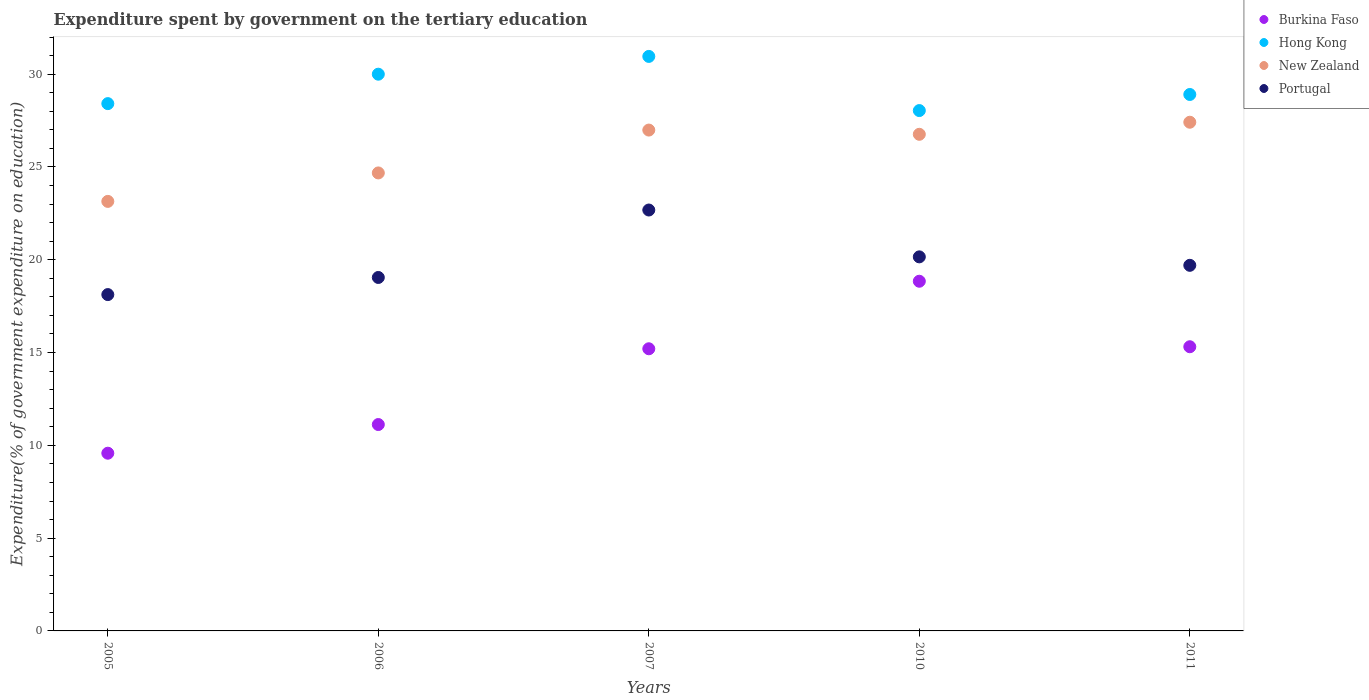How many different coloured dotlines are there?
Ensure brevity in your answer.  4. Is the number of dotlines equal to the number of legend labels?
Ensure brevity in your answer.  Yes. What is the expenditure spent by government on the tertiary education in Hong Kong in 2005?
Your answer should be very brief. 28.41. Across all years, what is the maximum expenditure spent by government on the tertiary education in Burkina Faso?
Provide a short and direct response. 18.84. Across all years, what is the minimum expenditure spent by government on the tertiary education in New Zealand?
Give a very brief answer. 23.14. In which year was the expenditure spent by government on the tertiary education in New Zealand maximum?
Offer a terse response. 2011. In which year was the expenditure spent by government on the tertiary education in New Zealand minimum?
Make the answer very short. 2005. What is the total expenditure spent by government on the tertiary education in New Zealand in the graph?
Offer a very short reply. 128.97. What is the difference between the expenditure spent by government on the tertiary education in Portugal in 2007 and that in 2011?
Keep it short and to the point. 2.98. What is the difference between the expenditure spent by government on the tertiary education in New Zealand in 2011 and the expenditure spent by government on the tertiary education in Hong Kong in 2010?
Provide a short and direct response. -0.63. What is the average expenditure spent by government on the tertiary education in Portugal per year?
Make the answer very short. 19.94. In the year 2010, what is the difference between the expenditure spent by government on the tertiary education in Portugal and expenditure spent by government on the tertiary education in New Zealand?
Provide a short and direct response. -6.6. In how many years, is the expenditure spent by government on the tertiary education in Burkina Faso greater than 22 %?
Your response must be concise. 0. What is the ratio of the expenditure spent by government on the tertiary education in Portugal in 2005 to that in 2011?
Provide a succinct answer. 0.92. What is the difference between the highest and the second highest expenditure spent by government on the tertiary education in New Zealand?
Give a very brief answer. 0.42. What is the difference between the highest and the lowest expenditure spent by government on the tertiary education in Hong Kong?
Ensure brevity in your answer.  2.92. Is it the case that in every year, the sum of the expenditure spent by government on the tertiary education in Burkina Faso and expenditure spent by government on the tertiary education in New Zealand  is greater than the sum of expenditure spent by government on the tertiary education in Hong Kong and expenditure spent by government on the tertiary education in Portugal?
Provide a short and direct response. No. Is the expenditure spent by government on the tertiary education in Portugal strictly less than the expenditure spent by government on the tertiary education in New Zealand over the years?
Keep it short and to the point. Yes. How many dotlines are there?
Give a very brief answer. 4. Does the graph contain any zero values?
Keep it short and to the point. No. Where does the legend appear in the graph?
Your response must be concise. Top right. How many legend labels are there?
Ensure brevity in your answer.  4. How are the legend labels stacked?
Keep it short and to the point. Vertical. What is the title of the graph?
Your answer should be compact. Expenditure spent by government on the tertiary education. What is the label or title of the X-axis?
Your response must be concise. Years. What is the label or title of the Y-axis?
Your answer should be very brief. Expenditure(% of government expenditure on education). What is the Expenditure(% of government expenditure on education) of Burkina Faso in 2005?
Your response must be concise. 9.58. What is the Expenditure(% of government expenditure on education) in Hong Kong in 2005?
Make the answer very short. 28.41. What is the Expenditure(% of government expenditure on education) of New Zealand in 2005?
Make the answer very short. 23.14. What is the Expenditure(% of government expenditure on education) in Portugal in 2005?
Keep it short and to the point. 18.12. What is the Expenditure(% of government expenditure on education) of Burkina Faso in 2006?
Your answer should be very brief. 11.12. What is the Expenditure(% of government expenditure on education) in Hong Kong in 2006?
Offer a very short reply. 30. What is the Expenditure(% of government expenditure on education) in New Zealand in 2006?
Offer a terse response. 24.68. What is the Expenditure(% of government expenditure on education) of Portugal in 2006?
Your answer should be compact. 19.04. What is the Expenditure(% of government expenditure on education) in Burkina Faso in 2007?
Provide a short and direct response. 15.2. What is the Expenditure(% of government expenditure on education) in Hong Kong in 2007?
Your answer should be very brief. 30.95. What is the Expenditure(% of government expenditure on education) in New Zealand in 2007?
Your response must be concise. 26.99. What is the Expenditure(% of government expenditure on education) of Portugal in 2007?
Provide a short and direct response. 22.68. What is the Expenditure(% of government expenditure on education) in Burkina Faso in 2010?
Provide a succinct answer. 18.84. What is the Expenditure(% of government expenditure on education) in Hong Kong in 2010?
Your answer should be compact. 28.04. What is the Expenditure(% of government expenditure on education) in New Zealand in 2010?
Your response must be concise. 26.76. What is the Expenditure(% of government expenditure on education) in Portugal in 2010?
Offer a terse response. 20.15. What is the Expenditure(% of government expenditure on education) in Burkina Faso in 2011?
Keep it short and to the point. 15.31. What is the Expenditure(% of government expenditure on education) in Hong Kong in 2011?
Ensure brevity in your answer.  28.9. What is the Expenditure(% of government expenditure on education) in New Zealand in 2011?
Offer a very short reply. 27.41. What is the Expenditure(% of government expenditure on education) in Portugal in 2011?
Your answer should be very brief. 19.7. Across all years, what is the maximum Expenditure(% of government expenditure on education) in Burkina Faso?
Your response must be concise. 18.84. Across all years, what is the maximum Expenditure(% of government expenditure on education) of Hong Kong?
Keep it short and to the point. 30.95. Across all years, what is the maximum Expenditure(% of government expenditure on education) of New Zealand?
Keep it short and to the point. 27.41. Across all years, what is the maximum Expenditure(% of government expenditure on education) of Portugal?
Your response must be concise. 22.68. Across all years, what is the minimum Expenditure(% of government expenditure on education) in Burkina Faso?
Provide a short and direct response. 9.58. Across all years, what is the minimum Expenditure(% of government expenditure on education) of Hong Kong?
Offer a very short reply. 28.04. Across all years, what is the minimum Expenditure(% of government expenditure on education) of New Zealand?
Ensure brevity in your answer.  23.14. Across all years, what is the minimum Expenditure(% of government expenditure on education) in Portugal?
Your response must be concise. 18.12. What is the total Expenditure(% of government expenditure on education) of Burkina Faso in the graph?
Your response must be concise. 70.05. What is the total Expenditure(% of government expenditure on education) in Hong Kong in the graph?
Ensure brevity in your answer.  146.3. What is the total Expenditure(% of government expenditure on education) of New Zealand in the graph?
Your response must be concise. 128.97. What is the total Expenditure(% of government expenditure on education) in Portugal in the graph?
Your response must be concise. 99.7. What is the difference between the Expenditure(% of government expenditure on education) in Burkina Faso in 2005 and that in 2006?
Your answer should be compact. -1.54. What is the difference between the Expenditure(% of government expenditure on education) in Hong Kong in 2005 and that in 2006?
Keep it short and to the point. -1.59. What is the difference between the Expenditure(% of government expenditure on education) of New Zealand in 2005 and that in 2006?
Give a very brief answer. -1.53. What is the difference between the Expenditure(% of government expenditure on education) of Portugal in 2005 and that in 2006?
Give a very brief answer. -0.92. What is the difference between the Expenditure(% of government expenditure on education) of Burkina Faso in 2005 and that in 2007?
Ensure brevity in your answer.  -5.63. What is the difference between the Expenditure(% of government expenditure on education) of Hong Kong in 2005 and that in 2007?
Provide a short and direct response. -2.54. What is the difference between the Expenditure(% of government expenditure on education) in New Zealand in 2005 and that in 2007?
Keep it short and to the point. -3.84. What is the difference between the Expenditure(% of government expenditure on education) in Portugal in 2005 and that in 2007?
Give a very brief answer. -4.56. What is the difference between the Expenditure(% of government expenditure on education) in Burkina Faso in 2005 and that in 2010?
Provide a succinct answer. -9.27. What is the difference between the Expenditure(% of government expenditure on education) in Hong Kong in 2005 and that in 2010?
Provide a succinct answer. 0.37. What is the difference between the Expenditure(% of government expenditure on education) of New Zealand in 2005 and that in 2010?
Make the answer very short. -3.61. What is the difference between the Expenditure(% of government expenditure on education) in Portugal in 2005 and that in 2010?
Keep it short and to the point. -2.03. What is the difference between the Expenditure(% of government expenditure on education) in Burkina Faso in 2005 and that in 2011?
Offer a very short reply. -5.74. What is the difference between the Expenditure(% of government expenditure on education) in Hong Kong in 2005 and that in 2011?
Your response must be concise. -0.49. What is the difference between the Expenditure(% of government expenditure on education) of New Zealand in 2005 and that in 2011?
Ensure brevity in your answer.  -4.27. What is the difference between the Expenditure(% of government expenditure on education) of Portugal in 2005 and that in 2011?
Offer a terse response. -1.58. What is the difference between the Expenditure(% of government expenditure on education) of Burkina Faso in 2006 and that in 2007?
Provide a succinct answer. -4.08. What is the difference between the Expenditure(% of government expenditure on education) in Hong Kong in 2006 and that in 2007?
Offer a terse response. -0.96. What is the difference between the Expenditure(% of government expenditure on education) of New Zealand in 2006 and that in 2007?
Make the answer very short. -2.31. What is the difference between the Expenditure(% of government expenditure on education) in Portugal in 2006 and that in 2007?
Offer a very short reply. -3.63. What is the difference between the Expenditure(% of government expenditure on education) in Burkina Faso in 2006 and that in 2010?
Give a very brief answer. -7.72. What is the difference between the Expenditure(% of government expenditure on education) in Hong Kong in 2006 and that in 2010?
Your answer should be compact. 1.96. What is the difference between the Expenditure(% of government expenditure on education) of New Zealand in 2006 and that in 2010?
Give a very brief answer. -2.08. What is the difference between the Expenditure(% of government expenditure on education) in Portugal in 2006 and that in 2010?
Keep it short and to the point. -1.11. What is the difference between the Expenditure(% of government expenditure on education) in Burkina Faso in 2006 and that in 2011?
Give a very brief answer. -4.19. What is the difference between the Expenditure(% of government expenditure on education) in Hong Kong in 2006 and that in 2011?
Keep it short and to the point. 1.09. What is the difference between the Expenditure(% of government expenditure on education) in New Zealand in 2006 and that in 2011?
Provide a succinct answer. -2.73. What is the difference between the Expenditure(% of government expenditure on education) in Portugal in 2006 and that in 2011?
Your response must be concise. -0.65. What is the difference between the Expenditure(% of government expenditure on education) in Burkina Faso in 2007 and that in 2010?
Your response must be concise. -3.64. What is the difference between the Expenditure(% of government expenditure on education) of Hong Kong in 2007 and that in 2010?
Give a very brief answer. 2.92. What is the difference between the Expenditure(% of government expenditure on education) in New Zealand in 2007 and that in 2010?
Your response must be concise. 0.23. What is the difference between the Expenditure(% of government expenditure on education) in Portugal in 2007 and that in 2010?
Offer a terse response. 2.52. What is the difference between the Expenditure(% of government expenditure on education) in Burkina Faso in 2007 and that in 2011?
Your answer should be very brief. -0.11. What is the difference between the Expenditure(% of government expenditure on education) in Hong Kong in 2007 and that in 2011?
Your answer should be very brief. 2.05. What is the difference between the Expenditure(% of government expenditure on education) in New Zealand in 2007 and that in 2011?
Make the answer very short. -0.42. What is the difference between the Expenditure(% of government expenditure on education) in Portugal in 2007 and that in 2011?
Your answer should be very brief. 2.98. What is the difference between the Expenditure(% of government expenditure on education) in Burkina Faso in 2010 and that in 2011?
Offer a very short reply. 3.53. What is the difference between the Expenditure(% of government expenditure on education) of Hong Kong in 2010 and that in 2011?
Make the answer very short. -0.87. What is the difference between the Expenditure(% of government expenditure on education) of New Zealand in 2010 and that in 2011?
Keep it short and to the point. -0.65. What is the difference between the Expenditure(% of government expenditure on education) of Portugal in 2010 and that in 2011?
Give a very brief answer. 0.46. What is the difference between the Expenditure(% of government expenditure on education) in Burkina Faso in 2005 and the Expenditure(% of government expenditure on education) in Hong Kong in 2006?
Keep it short and to the point. -20.42. What is the difference between the Expenditure(% of government expenditure on education) of Burkina Faso in 2005 and the Expenditure(% of government expenditure on education) of New Zealand in 2006?
Ensure brevity in your answer.  -15.1. What is the difference between the Expenditure(% of government expenditure on education) of Burkina Faso in 2005 and the Expenditure(% of government expenditure on education) of Portugal in 2006?
Provide a succinct answer. -9.47. What is the difference between the Expenditure(% of government expenditure on education) in Hong Kong in 2005 and the Expenditure(% of government expenditure on education) in New Zealand in 2006?
Provide a succinct answer. 3.73. What is the difference between the Expenditure(% of government expenditure on education) in Hong Kong in 2005 and the Expenditure(% of government expenditure on education) in Portugal in 2006?
Keep it short and to the point. 9.37. What is the difference between the Expenditure(% of government expenditure on education) of New Zealand in 2005 and the Expenditure(% of government expenditure on education) of Portugal in 2006?
Offer a very short reply. 4.1. What is the difference between the Expenditure(% of government expenditure on education) in Burkina Faso in 2005 and the Expenditure(% of government expenditure on education) in Hong Kong in 2007?
Make the answer very short. -21.38. What is the difference between the Expenditure(% of government expenditure on education) of Burkina Faso in 2005 and the Expenditure(% of government expenditure on education) of New Zealand in 2007?
Provide a succinct answer. -17.41. What is the difference between the Expenditure(% of government expenditure on education) in Burkina Faso in 2005 and the Expenditure(% of government expenditure on education) in Portugal in 2007?
Your response must be concise. -13.1. What is the difference between the Expenditure(% of government expenditure on education) of Hong Kong in 2005 and the Expenditure(% of government expenditure on education) of New Zealand in 2007?
Your answer should be very brief. 1.42. What is the difference between the Expenditure(% of government expenditure on education) in Hong Kong in 2005 and the Expenditure(% of government expenditure on education) in Portugal in 2007?
Keep it short and to the point. 5.73. What is the difference between the Expenditure(% of government expenditure on education) of New Zealand in 2005 and the Expenditure(% of government expenditure on education) of Portugal in 2007?
Offer a terse response. 0.46. What is the difference between the Expenditure(% of government expenditure on education) of Burkina Faso in 2005 and the Expenditure(% of government expenditure on education) of Hong Kong in 2010?
Offer a terse response. -18.46. What is the difference between the Expenditure(% of government expenditure on education) in Burkina Faso in 2005 and the Expenditure(% of government expenditure on education) in New Zealand in 2010?
Give a very brief answer. -17.18. What is the difference between the Expenditure(% of government expenditure on education) in Burkina Faso in 2005 and the Expenditure(% of government expenditure on education) in Portugal in 2010?
Keep it short and to the point. -10.58. What is the difference between the Expenditure(% of government expenditure on education) of Hong Kong in 2005 and the Expenditure(% of government expenditure on education) of New Zealand in 2010?
Give a very brief answer. 1.65. What is the difference between the Expenditure(% of government expenditure on education) of Hong Kong in 2005 and the Expenditure(% of government expenditure on education) of Portugal in 2010?
Offer a terse response. 8.26. What is the difference between the Expenditure(% of government expenditure on education) of New Zealand in 2005 and the Expenditure(% of government expenditure on education) of Portugal in 2010?
Offer a very short reply. 2.99. What is the difference between the Expenditure(% of government expenditure on education) in Burkina Faso in 2005 and the Expenditure(% of government expenditure on education) in Hong Kong in 2011?
Ensure brevity in your answer.  -19.33. What is the difference between the Expenditure(% of government expenditure on education) in Burkina Faso in 2005 and the Expenditure(% of government expenditure on education) in New Zealand in 2011?
Your answer should be very brief. -17.83. What is the difference between the Expenditure(% of government expenditure on education) in Burkina Faso in 2005 and the Expenditure(% of government expenditure on education) in Portugal in 2011?
Ensure brevity in your answer.  -10.12. What is the difference between the Expenditure(% of government expenditure on education) in Hong Kong in 2005 and the Expenditure(% of government expenditure on education) in Portugal in 2011?
Offer a terse response. 8.71. What is the difference between the Expenditure(% of government expenditure on education) of New Zealand in 2005 and the Expenditure(% of government expenditure on education) of Portugal in 2011?
Provide a succinct answer. 3.44. What is the difference between the Expenditure(% of government expenditure on education) of Burkina Faso in 2006 and the Expenditure(% of government expenditure on education) of Hong Kong in 2007?
Provide a succinct answer. -19.83. What is the difference between the Expenditure(% of government expenditure on education) of Burkina Faso in 2006 and the Expenditure(% of government expenditure on education) of New Zealand in 2007?
Give a very brief answer. -15.87. What is the difference between the Expenditure(% of government expenditure on education) in Burkina Faso in 2006 and the Expenditure(% of government expenditure on education) in Portugal in 2007?
Your answer should be very brief. -11.56. What is the difference between the Expenditure(% of government expenditure on education) of Hong Kong in 2006 and the Expenditure(% of government expenditure on education) of New Zealand in 2007?
Provide a short and direct response. 3.01. What is the difference between the Expenditure(% of government expenditure on education) in Hong Kong in 2006 and the Expenditure(% of government expenditure on education) in Portugal in 2007?
Provide a succinct answer. 7.32. What is the difference between the Expenditure(% of government expenditure on education) of New Zealand in 2006 and the Expenditure(% of government expenditure on education) of Portugal in 2007?
Ensure brevity in your answer.  2. What is the difference between the Expenditure(% of government expenditure on education) in Burkina Faso in 2006 and the Expenditure(% of government expenditure on education) in Hong Kong in 2010?
Your response must be concise. -16.92. What is the difference between the Expenditure(% of government expenditure on education) of Burkina Faso in 2006 and the Expenditure(% of government expenditure on education) of New Zealand in 2010?
Offer a terse response. -15.64. What is the difference between the Expenditure(% of government expenditure on education) of Burkina Faso in 2006 and the Expenditure(% of government expenditure on education) of Portugal in 2010?
Your answer should be compact. -9.03. What is the difference between the Expenditure(% of government expenditure on education) in Hong Kong in 2006 and the Expenditure(% of government expenditure on education) in New Zealand in 2010?
Your response must be concise. 3.24. What is the difference between the Expenditure(% of government expenditure on education) in Hong Kong in 2006 and the Expenditure(% of government expenditure on education) in Portugal in 2010?
Give a very brief answer. 9.84. What is the difference between the Expenditure(% of government expenditure on education) in New Zealand in 2006 and the Expenditure(% of government expenditure on education) in Portugal in 2010?
Provide a short and direct response. 4.52. What is the difference between the Expenditure(% of government expenditure on education) of Burkina Faso in 2006 and the Expenditure(% of government expenditure on education) of Hong Kong in 2011?
Offer a terse response. -17.78. What is the difference between the Expenditure(% of government expenditure on education) of Burkina Faso in 2006 and the Expenditure(% of government expenditure on education) of New Zealand in 2011?
Make the answer very short. -16.29. What is the difference between the Expenditure(% of government expenditure on education) of Burkina Faso in 2006 and the Expenditure(% of government expenditure on education) of Portugal in 2011?
Offer a very short reply. -8.58. What is the difference between the Expenditure(% of government expenditure on education) of Hong Kong in 2006 and the Expenditure(% of government expenditure on education) of New Zealand in 2011?
Your response must be concise. 2.59. What is the difference between the Expenditure(% of government expenditure on education) in Hong Kong in 2006 and the Expenditure(% of government expenditure on education) in Portugal in 2011?
Your answer should be very brief. 10.3. What is the difference between the Expenditure(% of government expenditure on education) in New Zealand in 2006 and the Expenditure(% of government expenditure on education) in Portugal in 2011?
Offer a terse response. 4.98. What is the difference between the Expenditure(% of government expenditure on education) of Burkina Faso in 2007 and the Expenditure(% of government expenditure on education) of Hong Kong in 2010?
Offer a very short reply. -12.83. What is the difference between the Expenditure(% of government expenditure on education) in Burkina Faso in 2007 and the Expenditure(% of government expenditure on education) in New Zealand in 2010?
Give a very brief answer. -11.56. What is the difference between the Expenditure(% of government expenditure on education) in Burkina Faso in 2007 and the Expenditure(% of government expenditure on education) in Portugal in 2010?
Ensure brevity in your answer.  -4.95. What is the difference between the Expenditure(% of government expenditure on education) of Hong Kong in 2007 and the Expenditure(% of government expenditure on education) of New Zealand in 2010?
Offer a very short reply. 4.2. What is the difference between the Expenditure(% of government expenditure on education) of Hong Kong in 2007 and the Expenditure(% of government expenditure on education) of Portugal in 2010?
Keep it short and to the point. 10.8. What is the difference between the Expenditure(% of government expenditure on education) in New Zealand in 2007 and the Expenditure(% of government expenditure on education) in Portugal in 2010?
Offer a very short reply. 6.83. What is the difference between the Expenditure(% of government expenditure on education) of Burkina Faso in 2007 and the Expenditure(% of government expenditure on education) of Hong Kong in 2011?
Keep it short and to the point. -13.7. What is the difference between the Expenditure(% of government expenditure on education) in Burkina Faso in 2007 and the Expenditure(% of government expenditure on education) in New Zealand in 2011?
Offer a terse response. -12.21. What is the difference between the Expenditure(% of government expenditure on education) in Burkina Faso in 2007 and the Expenditure(% of government expenditure on education) in Portugal in 2011?
Provide a short and direct response. -4.5. What is the difference between the Expenditure(% of government expenditure on education) of Hong Kong in 2007 and the Expenditure(% of government expenditure on education) of New Zealand in 2011?
Give a very brief answer. 3.55. What is the difference between the Expenditure(% of government expenditure on education) of Hong Kong in 2007 and the Expenditure(% of government expenditure on education) of Portugal in 2011?
Offer a very short reply. 11.26. What is the difference between the Expenditure(% of government expenditure on education) in New Zealand in 2007 and the Expenditure(% of government expenditure on education) in Portugal in 2011?
Keep it short and to the point. 7.29. What is the difference between the Expenditure(% of government expenditure on education) in Burkina Faso in 2010 and the Expenditure(% of government expenditure on education) in Hong Kong in 2011?
Provide a succinct answer. -10.06. What is the difference between the Expenditure(% of government expenditure on education) of Burkina Faso in 2010 and the Expenditure(% of government expenditure on education) of New Zealand in 2011?
Your answer should be very brief. -8.57. What is the difference between the Expenditure(% of government expenditure on education) of Burkina Faso in 2010 and the Expenditure(% of government expenditure on education) of Portugal in 2011?
Your answer should be very brief. -0.86. What is the difference between the Expenditure(% of government expenditure on education) of Hong Kong in 2010 and the Expenditure(% of government expenditure on education) of New Zealand in 2011?
Give a very brief answer. 0.63. What is the difference between the Expenditure(% of government expenditure on education) of Hong Kong in 2010 and the Expenditure(% of government expenditure on education) of Portugal in 2011?
Keep it short and to the point. 8.34. What is the difference between the Expenditure(% of government expenditure on education) in New Zealand in 2010 and the Expenditure(% of government expenditure on education) in Portugal in 2011?
Your response must be concise. 7.06. What is the average Expenditure(% of government expenditure on education) of Burkina Faso per year?
Give a very brief answer. 14.01. What is the average Expenditure(% of government expenditure on education) of Hong Kong per year?
Provide a short and direct response. 29.26. What is the average Expenditure(% of government expenditure on education) in New Zealand per year?
Give a very brief answer. 25.79. What is the average Expenditure(% of government expenditure on education) in Portugal per year?
Your answer should be very brief. 19.94. In the year 2005, what is the difference between the Expenditure(% of government expenditure on education) in Burkina Faso and Expenditure(% of government expenditure on education) in Hong Kong?
Provide a short and direct response. -18.84. In the year 2005, what is the difference between the Expenditure(% of government expenditure on education) in Burkina Faso and Expenditure(% of government expenditure on education) in New Zealand?
Your answer should be very brief. -13.57. In the year 2005, what is the difference between the Expenditure(% of government expenditure on education) of Burkina Faso and Expenditure(% of government expenditure on education) of Portugal?
Offer a terse response. -8.55. In the year 2005, what is the difference between the Expenditure(% of government expenditure on education) in Hong Kong and Expenditure(% of government expenditure on education) in New Zealand?
Provide a succinct answer. 5.27. In the year 2005, what is the difference between the Expenditure(% of government expenditure on education) of Hong Kong and Expenditure(% of government expenditure on education) of Portugal?
Your answer should be compact. 10.29. In the year 2005, what is the difference between the Expenditure(% of government expenditure on education) of New Zealand and Expenditure(% of government expenditure on education) of Portugal?
Your answer should be very brief. 5.02. In the year 2006, what is the difference between the Expenditure(% of government expenditure on education) in Burkina Faso and Expenditure(% of government expenditure on education) in Hong Kong?
Offer a very short reply. -18.88. In the year 2006, what is the difference between the Expenditure(% of government expenditure on education) in Burkina Faso and Expenditure(% of government expenditure on education) in New Zealand?
Your answer should be very brief. -13.56. In the year 2006, what is the difference between the Expenditure(% of government expenditure on education) of Burkina Faso and Expenditure(% of government expenditure on education) of Portugal?
Offer a terse response. -7.92. In the year 2006, what is the difference between the Expenditure(% of government expenditure on education) in Hong Kong and Expenditure(% of government expenditure on education) in New Zealand?
Give a very brief answer. 5.32. In the year 2006, what is the difference between the Expenditure(% of government expenditure on education) in Hong Kong and Expenditure(% of government expenditure on education) in Portugal?
Your response must be concise. 10.95. In the year 2006, what is the difference between the Expenditure(% of government expenditure on education) of New Zealand and Expenditure(% of government expenditure on education) of Portugal?
Keep it short and to the point. 5.63. In the year 2007, what is the difference between the Expenditure(% of government expenditure on education) of Burkina Faso and Expenditure(% of government expenditure on education) of Hong Kong?
Give a very brief answer. -15.75. In the year 2007, what is the difference between the Expenditure(% of government expenditure on education) of Burkina Faso and Expenditure(% of government expenditure on education) of New Zealand?
Your response must be concise. -11.78. In the year 2007, what is the difference between the Expenditure(% of government expenditure on education) of Burkina Faso and Expenditure(% of government expenditure on education) of Portugal?
Your answer should be compact. -7.48. In the year 2007, what is the difference between the Expenditure(% of government expenditure on education) of Hong Kong and Expenditure(% of government expenditure on education) of New Zealand?
Ensure brevity in your answer.  3.97. In the year 2007, what is the difference between the Expenditure(% of government expenditure on education) of Hong Kong and Expenditure(% of government expenditure on education) of Portugal?
Make the answer very short. 8.28. In the year 2007, what is the difference between the Expenditure(% of government expenditure on education) of New Zealand and Expenditure(% of government expenditure on education) of Portugal?
Your answer should be very brief. 4.31. In the year 2010, what is the difference between the Expenditure(% of government expenditure on education) of Burkina Faso and Expenditure(% of government expenditure on education) of Hong Kong?
Give a very brief answer. -9.2. In the year 2010, what is the difference between the Expenditure(% of government expenditure on education) of Burkina Faso and Expenditure(% of government expenditure on education) of New Zealand?
Make the answer very short. -7.92. In the year 2010, what is the difference between the Expenditure(% of government expenditure on education) in Burkina Faso and Expenditure(% of government expenditure on education) in Portugal?
Keep it short and to the point. -1.31. In the year 2010, what is the difference between the Expenditure(% of government expenditure on education) of Hong Kong and Expenditure(% of government expenditure on education) of New Zealand?
Ensure brevity in your answer.  1.28. In the year 2010, what is the difference between the Expenditure(% of government expenditure on education) of Hong Kong and Expenditure(% of government expenditure on education) of Portugal?
Offer a very short reply. 7.88. In the year 2010, what is the difference between the Expenditure(% of government expenditure on education) of New Zealand and Expenditure(% of government expenditure on education) of Portugal?
Provide a succinct answer. 6.6. In the year 2011, what is the difference between the Expenditure(% of government expenditure on education) of Burkina Faso and Expenditure(% of government expenditure on education) of Hong Kong?
Your answer should be compact. -13.59. In the year 2011, what is the difference between the Expenditure(% of government expenditure on education) in Burkina Faso and Expenditure(% of government expenditure on education) in New Zealand?
Give a very brief answer. -12.1. In the year 2011, what is the difference between the Expenditure(% of government expenditure on education) in Burkina Faso and Expenditure(% of government expenditure on education) in Portugal?
Provide a succinct answer. -4.39. In the year 2011, what is the difference between the Expenditure(% of government expenditure on education) in Hong Kong and Expenditure(% of government expenditure on education) in New Zealand?
Your answer should be compact. 1.5. In the year 2011, what is the difference between the Expenditure(% of government expenditure on education) of Hong Kong and Expenditure(% of government expenditure on education) of Portugal?
Make the answer very short. 9.2. In the year 2011, what is the difference between the Expenditure(% of government expenditure on education) in New Zealand and Expenditure(% of government expenditure on education) in Portugal?
Offer a very short reply. 7.71. What is the ratio of the Expenditure(% of government expenditure on education) of Burkina Faso in 2005 to that in 2006?
Provide a short and direct response. 0.86. What is the ratio of the Expenditure(% of government expenditure on education) in Hong Kong in 2005 to that in 2006?
Provide a succinct answer. 0.95. What is the ratio of the Expenditure(% of government expenditure on education) of New Zealand in 2005 to that in 2006?
Offer a terse response. 0.94. What is the ratio of the Expenditure(% of government expenditure on education) of Portugal in 2005 to that in 2006?
Keep it short and to the point. 0.95. What is the ratio of the Expenditure(% of government expenditure on education) of Burkina Faso in 2005 to that in 2007?
Give a very brief answer. 0.63. What is the ratio of the Expenditure(% of government expenditure on education) of Hong Kong in 2005 to that in 2007?
Give a very brief answer. 0.92. What is the ratio of the Expenditure(% of government expenditure on education) in New Zealand in 2005 to that in 2007?
Provide a succinct answer. 0.86. What is the ratio of the Expenditure(% of government expenditure on education) of Portugal in 2005 to that in 2007?
Offer a very short reply. 0.8. What is the ratio of the Expenditure(% of government expenditure on education) in Burkina Faso in 2005 to that in 2010?
Your response must be concise. 0.51. What is the ratio of the Expenditure(% of government expenditure on education) in Hong Kong in 2005 to that in 2010?
Offer a terse response. 1.01. What is the ratio of the Expenditure(% of government expenditure on education) in New Zealand in 2005 to that in 2010?
Your answer should be very brief. 0.86. What is the ratio of the Expenditure(% of government expenditure on education) in Portugal in 2005 to that in 2010?
Offer a very short reply. 0.9. What is the ratio of the Expenditure(% of government expenditure on education) in Burkina Faso in 2005 to that in 2011?
Provide a short and direct response. 0.63. What is the ratio of the Expenditure(% of government expenditure on education) in New Zealand in 2005 to that in 2011?
Offer a very short reply. 0.84. What is the ratio of the Expenditure(% of government expenditure on education) in Portugal in 2005 to that in 2011?
Keep it short and to the point. 0.92. What is the ratio of the Expenditure(% of government expenditure on education) of Burkina Faso in 2006 to that in 2007?
Provide a short and direct response. 0.73. What is the ratio of the Expenditure(% of government expenditure on education) of Hong Kong in 2006 to that in 2007?
Ensure brevity in your answer.  0.97. What is the ratio of the Expenditure(% of government expenditure on education) of New Zealand in 2006 to that in 2007?
Provide a succinct answer. 0.91. What is the ratio of the Expenditure(% of government expenditure on education) of Portugal in 2006 to that in 2007?
Give a very brief answer. 0.84. What is the ratio of the Expenditure(% of government expenditure on education) in Burkina Faso in 2006 to that in 2010?
Keep it short and to the point. 0.59. What is the ratio of the Expenditure(% of government expenditure on education) of Hong Kong in 2006 to that in 2010?
Offer a terse response. 1.07. What is the ratio of the Expenditure(% of government expenditure on education) in New Zealand in 2006 to that in 2010?
Offer a very short reply. 0.92. What is the ratio of the Expenditure(% of government expenditure on education) of Portugal in 2006 to that in 2010?
Your answer should be very brief. 0.94. What is the ratio of the Expenditure(% of government expenditure on education) of Burkina Faso in 2006 to that in 2011?
Offer a terse response. 0.73. What is the ratio of the Expenditure(% of government expenditure on education) of Hong Kong in 2006 to that in 2011?
Keep it short and to the point. 1.04. What is the ratio of the Expenditure(% of government expenditure on education) in New Zealand in 2006 to that in 2011?
Keep it short and to the point. 0.9. What is the ratio of the Expenditure(% of government expenditure on education) in Portugal in 2006 to that in 2011?
Your answer should be very brief. 0.97. What is the ratio of the Expenditure(% of government expenditure on education) in Burkina Faso in 2007 to that in 2010?
Ensure brevity in your answer.  0.81. What is the ratio of the Expenditure(% of government expenditure on education) of Hong Kong in 2007 to that in 2010?
Make the answer very short. 1.1. What is the ratio of the Expenditure(% of government expenditure on education) of New Zealand in 2007 to that in 2010?
Give a very brief answer. 1.01. What is the ratio of the Expenditure(% of government expenditure on education) of Portugal in 2007 to that in 2010?
Offer a very short reply. 1.13. What is the ratio of the Expenditure(% of government expenditure on education) in Burkina Faso in 2007 to that in 2011?
Offer a very short reply. 0.99. What is the ratio of the Expenditure(% of government expenditure on education) of Hong Kong in 2007 to that in 2011?
Your response must be concise. 1.07. What is the ratio of the Expenditure(% of government expenditure on education) of New Zealand in 2007 to that in 2011?
Keep it short and to the point. 0.98. What is the ratio of the Expenditure(% of government expenditure on education) of Portugal in 2007 to that in 2011?
Give a very brief answer. 1.15. What is the ratio of the Expenditure(% of government expenditure on education) in Burkina Faso in 2010 to that in 2011?
Give a very brief answer. 1.23. What is the ratio of the Expenditure(% of government expenditure on education) of New Zealand in 2010 to that in 2011?
Your answer should be very brief. 0.98. What is the ratio of the Expenditure(% of government expenditure on education) in Portugal in 2010 to that in 2011?
Keep it short and to the point. 1.02. What is the difference between the highest and the second highest Expenditure(% of government expenditure on education) of Burkina Faso?
Make the answer very short. 3.53. What is the difference between the highest and the second highest Expenditure(% of government expenditure on education) of Hong Kong?
Ensure brevity in your answer.  0.96. What is the difference between the highest and the second highest Expenditure(% of government expenditure on education) in New Zealand?
Keep it short and to the point. 0.42. What is the difference between the highest and the second highest Expenditure(% of government expenditure on education) in Portugal?
Your answer should be compact. 2.52. What is the difference between the highest and the lowest Expenditure(% of government expenditure on education) of Burkina Faso?
Give a very brief answer. 9.27. What is the difference between the highest and the lowest Expenditure(% of government expenditure on education) of Hong Kong?
Keep it short and to the point. 2.92. What is the difference between the highest and the lowest Expenditure(% of government expenditure on education) in New Zealand?
Keep it short and to the point. 4.27. What is the difference between the highest and the lowest Expenditure(% of government expenditure on education) in Portugal?
Give a very brief answer. 4.56. 